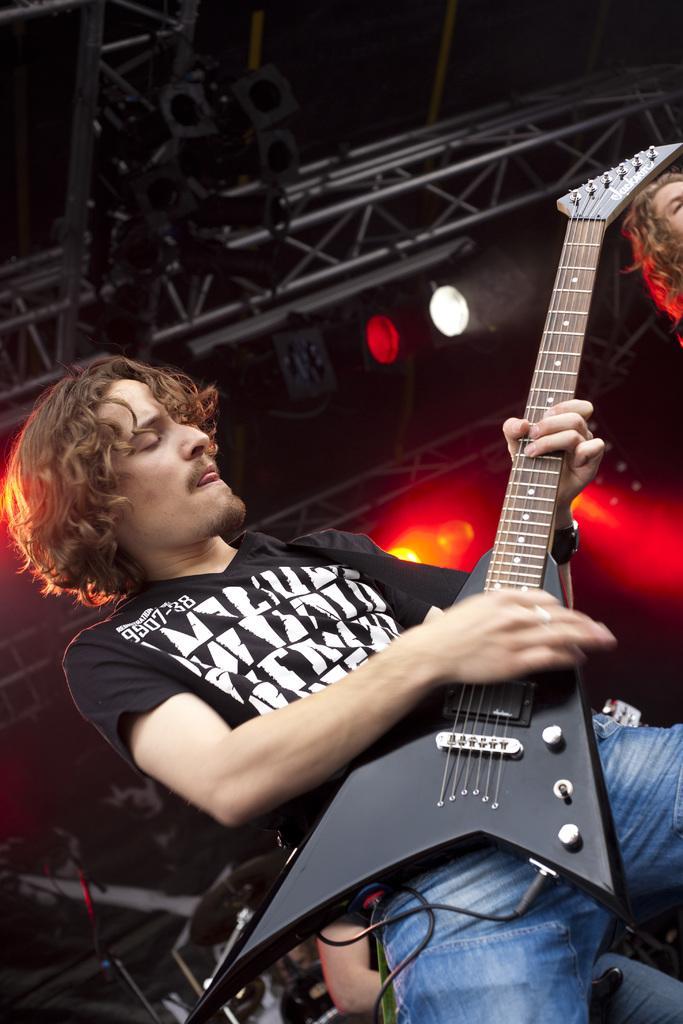Please provide a concise description of this image. Here is a man standing and playing guitar. At the right corner of the image I can see a woman's face. These are the show lights at the top. 